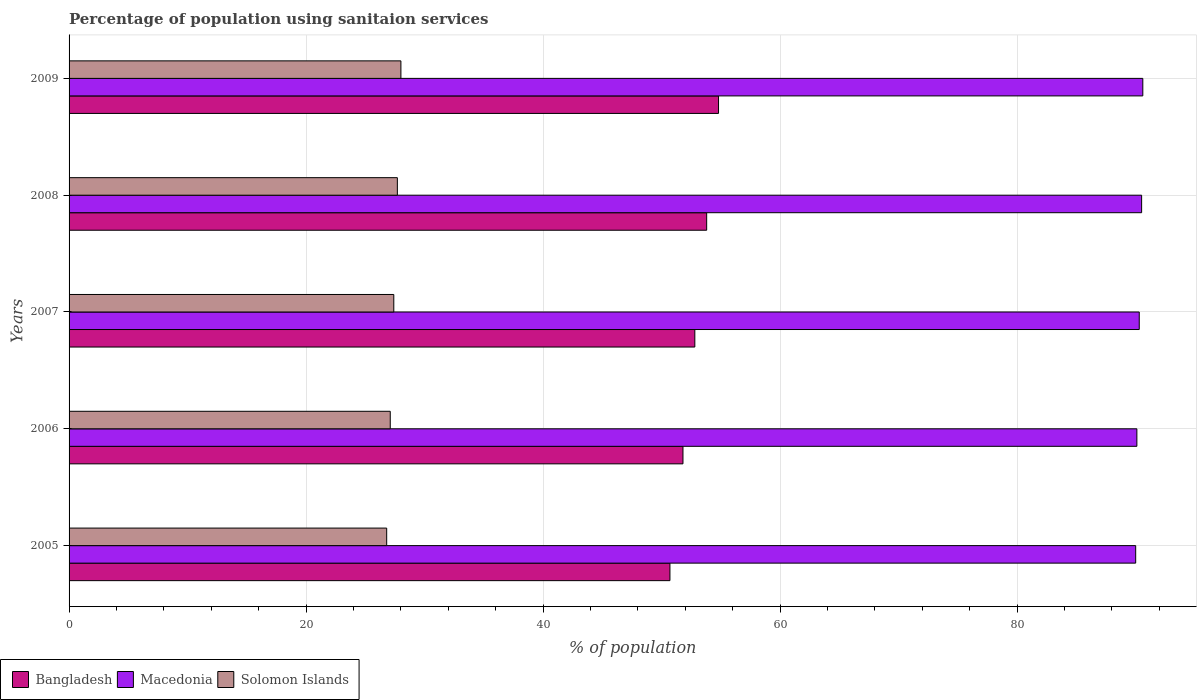Are the number of bars per tick equal to the number of legend labels?
Your answer should be very brief. Yes. How many bars are there on the 3rd tick from the bottom?
Offer a very short reply. 3. What is the percentage of population using sanitaion services in Solomon Islands in 2005?
Offer a very short reply. 26.8. Across all years, what is the maximum percentage of population using sanitaion services in Bangladesh?
Offer a terse response. 54.8. In which year was the percentage of population using sanitaion services in Solomon Islands maximum?
Provide a short and direct response. 2009. In which year was the percentage of population using sanitaion services in Solomon Islands minimum?
Make the answer very short. 2005. What is the total percentage of population using sanitaion services in Macedonia in the graph?
Keep it short and to the point. 451.5. What is the difference between the percentage of population using sanitaion services in Bangladesh in 2005 and the percentage of population using sanitaion services in Solomon Islands in 2008?
Your answer should be very brief. 23. What is the average percentage of population using sanitaion services in Solomon Islands per year?
Offer a terse response. 27.4. In the year 2007, what is the difference between the percentage of population using sanitaion services in Bangladesh and percentage of population using sanitaion services in Solomon Islands?
Your answer should be very brief. 25.4. What is the ratio of the percentage of population using sanitaion services in Solomon Islands in 2006 to that in 2009?
Offer a very short reply. 0.97. Is the percentage of population using sanitaion services in Solomon Islands in 2006 less than that in 2008?
Keep it short and to the point. Yes. What is the difference between the highest and the lowest percentage of population using sanitaion services in Macedonia?
Offer a very short reply. 0.6. In how many years, is the percentage of population using sanitaion services in Bangladesh greater than the average percentage of population using sanitaion services in Bangladesh taken over all years?
Keep it short and to the point. 3. Is the sum of the percentage of population using sanitaion services in Solomon Islands in 2005 and 2009 greater than the maximum percentage of population using sanitaion services in Macedonia across all years?
Your answer should be very brief. No. What does the 2nd bar from the top in 2009 represents?
Provide a succinct answer. Macedonia. What does the 2nd bar from the bottom in 2009 represents?
Provide a short and direct response. Macedonia. How many bars are there?
Your answer should be very brief. 15. Are all the bars in the graph horizontal?
Your answer should be compact. Yes. How many years are there in the graph?
Offer a terse response. 5. Are the values on the major ticks of X-axis written in scientific E-notation?
Offer a terse response. No. Does the graph contain any zero values?
Provide a succinct answer. No. Does the graph contain grids?
Provide a succinct answer. Yes. What is the title of the graph?
Make the answer very short. Percentage of population using sanitaion services. What is the label or title of the X-axis?
Keep it short and to the point. % of population. What is the % of population of Bangladesh in 2005?
Make the answer very short. 50.7. What is the % of population of Macedonia in 2005?
Keep it short and to the point. 90. What is the % of population in Solomon Islands in 2005?
Your response must be concise. 26.8. What is the % of population in Bangladesh in 2006?
Offer a very short reply. 51.8. What is the % of population in Macedonia in 2006?
Offer a very short reply. 90.1. What is the % of population in Solomon Islands in 2006?
Provide a succinct answer. 27.1. What is the % of population in Bangladesh in 2007?
Provide a short and direct response. 52.8. What is the % of population in Macedonia in 2007?
Give a very brief answer. 90.3. What is the % of population in Solomon Islands in 2007?
Offer a very short reply. 27.4. What is the % of population of Bangladesh in 2008?
Give a very brief answer. 53.8. What is the % of population of Macedonia in 2008?
Give a very brief answer. 90.5. What is the % of population of Solomon Islands in 2008?
Offer a terse response. 27.7. What is the % of population in Bangladesh in 2009?
Keep it short and to the point. 54.8. What is the % of population of Macedonia in 2009?
Give a very brief answer. 90.6. What is the % of population in Solomon Islands in 2009?
Your answer should be very brief. 28. Across all years, what is the maximum % of population in Bangladesh?
Keep it short and to the point. 54.8. Across all years, what is the maximum % of population in Macedonia?
Provide a short and direct response. 90.6. Across all years, what is the minimum % of population in Bangladesh?
Ensure brevity in your answer.  50.7. Across all years, what is the minimum % of population in Solomon Islands?
Ensure brevity in your answer.  26.8. What is the total % of population of Bangladesh in the graph?
Provide a short and direct response. 263.9. What is the total % of population of Macedonia in the graph?
Provide a short and direct response. 451.5. What is the total % of population in Solomon Islands in the graph?
Keep it short and to the point. 137. What is the difference between the % of population of Solomon Islands in 2005 and that in 2006?
Your answer should be compact. -0.3. What is the difference between the % of population in Bangladesh in 2005 and that in 2007?
Provide a succinct answer. -2.1. What is the difference between the % of population in Macedonia in 2005 and that in 2007?
Your answer should be compact. -0.3. What is the difference between the % of population of Solomon Islands in 2005 and that in 2007?
Your answer should be very brief. -0.6. What is the difference between the % of population of Bangladesh in 2005 and that in 2008?
Your answer should be compact. -3.1. What is the difference between the % of population of Macedonia in 2005 and that in 2008?
Provide a succinct answer. -0.5. What is the difference between the % of population of Solomon Islands in 2005 and that in 2008?
Keep it short and to the point. -0.9. What is the difference between the % of population of Bangladesh in 2005 and that in 2009?
Offer a very short reply. -4.1. What is the difference between the % of population in Macedonia in 2005 and that in 2009?
Give a very brief answer. -0.6. What is the difference between the % of population in Macedonia in 2006 and that in 2007?
Ensure brevity in your answer.  -0.2. What is the difference between the % of population in Macedonia in 2006 and that in 2008?
Keep it short and to the point. -0.4. What is the difference between the % of population of Bangladesh in 2007 and that in 2008?
Offer a very short reply. -1. What is the difference between the % of population in Solomon Islands in 2007 and that in 2008?
Offer a terse response. -0.3. What is the difference between the % of population in Bangladesh in 2007 and that in 2009?
Offer a terse response. -2. What is the difference between the % of population of Macedonia in 2007 and that in 2009?
Your response must be concise. -0.3. What is the difference between the % of population in Solomon Islands in 2007 and that in 2009?
Keep it short and to the point. -0.6. What is the difference between the % of population in Bangladesh in 2008 and that in 2009?
Your answer should be compact. -1. What is the difference between the % of population of Macedonia in 2008 and that in 2009?
Offer a terse response. -0.1. What is the difference between the % of population of Solomon Islands in 2008 and that in 2009?
Your answer should be compact. -0.3. What is the difference between the % of population in Bangladesh in 2005 and the % of population in Macedonia in 2006?
Your response must be concise. -39.4. What is the difference between the % of population of Bangladesh in 2005 and the % of population of Solomon Islands in 2006?
Your answer should be very brief. 23.6. What is the difference between the % of population of Macedonia in 2005 and the % of population of Solomon Islands in 2006?
Your answer should be very brief. 62.9. What is the difference between the % of population in Bangladesh in 2005 and the % of population in Macedonia in 2007?
Offer a terse response. -39.6. What is the difference between the % of population of Bangladesh in 2005 and the % of population of Solomon Islands in 2007?
Make the answer very short. 23.3. What is the difference between the % of population of Macedonia in 2005 and the % of population of Solomon Islands in 2007?
Give a very brief answer. 62.6. What is the difference between the % of population of Bangladesh in 2005 and the % of population of Macedonia in 2008?
Your response must be concise. -39.8. What is the difference between the % of population of Macedonia in 2005 and the % of population of Solomon Islands in 2008?
Keep it short and to the point. 62.3. What is the difference between the % of population of Bangladesh in 2005 and the % of population of Macedonia in 2009?
Your response must be concise. -39.9. What is the difference between the % of population of Bangladesh in 2005 and the % of population of Solomon Islands in 2009?
Your answer should be compact. 22.7. What is the difference between the % of population of Macedonia in 2005 and the % of population of Solomon Islands in 2009?
Provide a succinct answer. 62. What is the difference between the % of population in Bangladesh in 2006 and the % of population in Macedonia in 2007?
Offer a terse response. -38.5. What is the difference between the % of population in Bangladesh in 2006 and the % of population in Solomon Islands in 2007?
Your answer should be compact. 24.4. What is the difference between the % of population in Macedonia in 2006 and the % of population in Solomon Islands in 2007?
Your answer should be compact. 62.7. What is the difference between the % of population of Bangladesh in 2006 and the % of population of Macedonia in 2008?
Keep it short and to the point. -38.7. What is the difference between the % of population in Bangladesh in 2006 and the % of population in Solomon Islands in 2008?
Keep it short and to the point. 24.1. What is the difference between the % of population of Macedonia in 2006 and the % of population of Solomon Islands in 2008?
Keep it short and to the point. 62.4. What is the difference between the % of population of Bangladesh in 2006 and the % of population of Macedonia in 2009?
Make the answer very short. -38.8. What is the difference between the % of population of Bangladesh in 2006 and the % of population of Solomon Islands in 2009?
Make the answer very short. 23.8. What is the difference between the % of population of Macedonia in 2006 and the % of population of Solomon Islands in 2009?
Your response must be concise. 62.1. What is the difference between the % of population in Bangladesh in 2007 and the % of population in Macedonia in 2008?
Make the answer very short. -37.7. What is the difference between the % of population of Bangladesh in 2007 and the % of population of Solomon Islands in 2008?
Ensure brevity in your answer.  25.1. What is the difference between the % of population of Macedonia in 2007 and the % of population of Solomon Islands in 2008?
Your response must be concise. 62.6. What is the difference between the % of population in Bangladesh in 2007 and the % of population in Macedonia in 2009?
Your answer should be compact. -37.8. What is the difference between the % of population in Bangladesh in 2007 and the % of population in Solomon Islands in 2009?
Offer a very short reply. 24.8. What is the difference between the % of population in Macedonia in 2007 and the % of population in Solomon Islands in 2009?
Your answer should be compact. 62.3. What is the difference between the % of population of Bangladesh in 2008 and the % of population of Macedonia in 2009?
Keep it short and to the point. -36.8. What is the difference between the % of population of Bangladesh in 2008 and the % of population of Solomon Islands in 2009?
Keep it short and to the point. 25.8. What is the difference between the % of population of Macedonia in 2008 and the % of population of Solomon Islands in 2009?
Provide a short and direct response. 62.5. What is the average % of population in Bangladesh per year?
Provide a short and direct response. 52.78. What is the average % of population in Macedonia per year?
Your answer should be compact. 90.3. What is the average % of population in Solomon Islands per year?
Your response must be concise. 27.4. In the year 2005, what is the difference between the % of population in Bangladesh and % of population in Macedonia?
Your answer should be very brief. -39.3. In the year 2005, what is the difference between the % of population of Bangladesh and % of population of Solomon Islands?
Offer a very short reply. 23.9. In the year 2005, what is the difference between the % of population of Macedonia and % of population of Solomon Islands?
Your answer should be compact. 63.2. In the year 2006, what is the difference between the % of population of Bangladesh and % of population of Macedonia?
Provide a succinct answer. -38.3. In the year 2006, what is the difference between the % of population of Bangladesh and % of population of Solomon Islands?
Provide a succinct answer. 24.7. In the year 2007, what is the difference between the % of population of Bangladesh and % of population of Macedonia?
Offer a terse response. -37.5. In the year 2007, what is the difference between the % of population in Bangladesh and % of population in Solomon Islands?
Your response must be concise. 25.4. In the year 2007, what is the difference between the % of population in Macedonia and % of population in Solomon Islands?
Keep it short and to the point. 62.9. In the year 2008, what is the difference between the % of population of Bangladesh and % of population of Macedonia?
Give a very brief answer. -36.7. In the year 2008, what is the difference between the % of population of Bangladesh and % of population of Solomon Islands?
Give a very brief answer. 26.1. In the year 2008, what is the difference between the % of population in Macedonia and % of population in Solomon Islands?
Your response must be concise. 62.8. In the year 2009, what is the difference between the % of population of Bangladesh and % of population of Macedonia?
Provide a short and direct response. -35.8. In the year 2009, what is the difference between the % of population in Bangladesh and % of population in Solomon Islands?
Your response must be concise. 26.8. In the year 2009, what is the difference between the % of population in Macedonia and % of population in Solomon Islands?
Offer a terse response. 62.6. What is the ratio of the % of population of Bangladesh in 2005 to that in 2006?
Offer a very short reply. 0.98. What is the ratio of the % of population of Solomon Islands in 2005 to that in 2006?
Make the answer very short. 0.99. What is the ratio of the % of population of Bangladesh in 2005 to that in 2007?
Make the answer very short. 0.96. What is the ratio of the % of population in Macedonia in 2005 to that in 2007?
Your answer should be very brief. 1. What is the ratio of the % of population in Solomon Islands in 2005 to that in 2007?
Your answer should be compact. 0.98. What is the ratio of the % of population of Bangladesh in 2005 to that in 2008?
Give a very brief answer. 0.94. What is the ratio of the % of population in Macedonia in 2005 to that in 2008?
Keep it short and to the point. 0.99. What is the ratio of the % of population in Solomon Islands in 2005 to that in 2008?
Make the answer very short. 0.97. What is the ratio of the % of population in Bangladesh in 2005 to that in 2009?
Your answer should be very brief. 0.93. What is the ratio of the % of population in Solomon Islands in 2005 to that in 2009?
Your answer should be very brief. 0.96. What is the ratio of the % of population in Bangladesh in 2006 to that in 2007?
Offer a very short reply. 0.98. What is the ratio of the % of population of Macedonia in 2006 to that in 2007?
Provide a succinct answer. 1. What is the ratio of the % of population of Solomon Islands in 2006 to that in 2007?
Your response must be concise. 0.99. What is the ratio of the % of population of Bangladesh in 2006 to that in 2008?
Your response must be concise. 0.96. What is the ratio of the % of population of Macedonia in 2006 to that in 2008?
Your answer should be very brief. 1. What is the ratio of the % of population of Solomon Islands in 2006 to that in 2008?
Your response must be concise. 0.98. What is the ratio of the % of population in Bangladesh in 2006 to that in 2009?
Offer a very short reply. 0.95. What is the ratio of the % of population of Solomon Islands in 2006 to that in 2009?
Provide a short and direct response. 0.97. What is the ratio of the % of population of Bangladesh in 2007 to that in 2008?
Provide a short and direct response. 0.98. What is the ratio of the % of population in Solomon Islands in 2007 to that in 2008?
Your response must be concise. 0.99. What is the ratio of the % of population in Bangladesh in 2007 to that in 2009?
Your answer should be very brief. 0.96. What is the ratio of the % of population of Solomon Islands in 2007 to that in 2009?
Your response must be concise. 0.98. What is the ratio of the % of population in Bangladesh in 2008 to that in 2009?
Keep it short and to the point. 0.98. What is the ratio of the % of population in Solomon Islands in 2008 to that in 2009?
Your answer should be very brief. 0.99. What is the difference between the highest and the second highest % of population in Solomon Islands?
Offer a very short reply. 0.3. What is the difference between the highest and the lowest % of population of Bangladesh?
Your response must be concise. 4.1. What is the difference between the highest and the lowest % of population of Solomon Islands?
Offer a terse response. 1.2. 